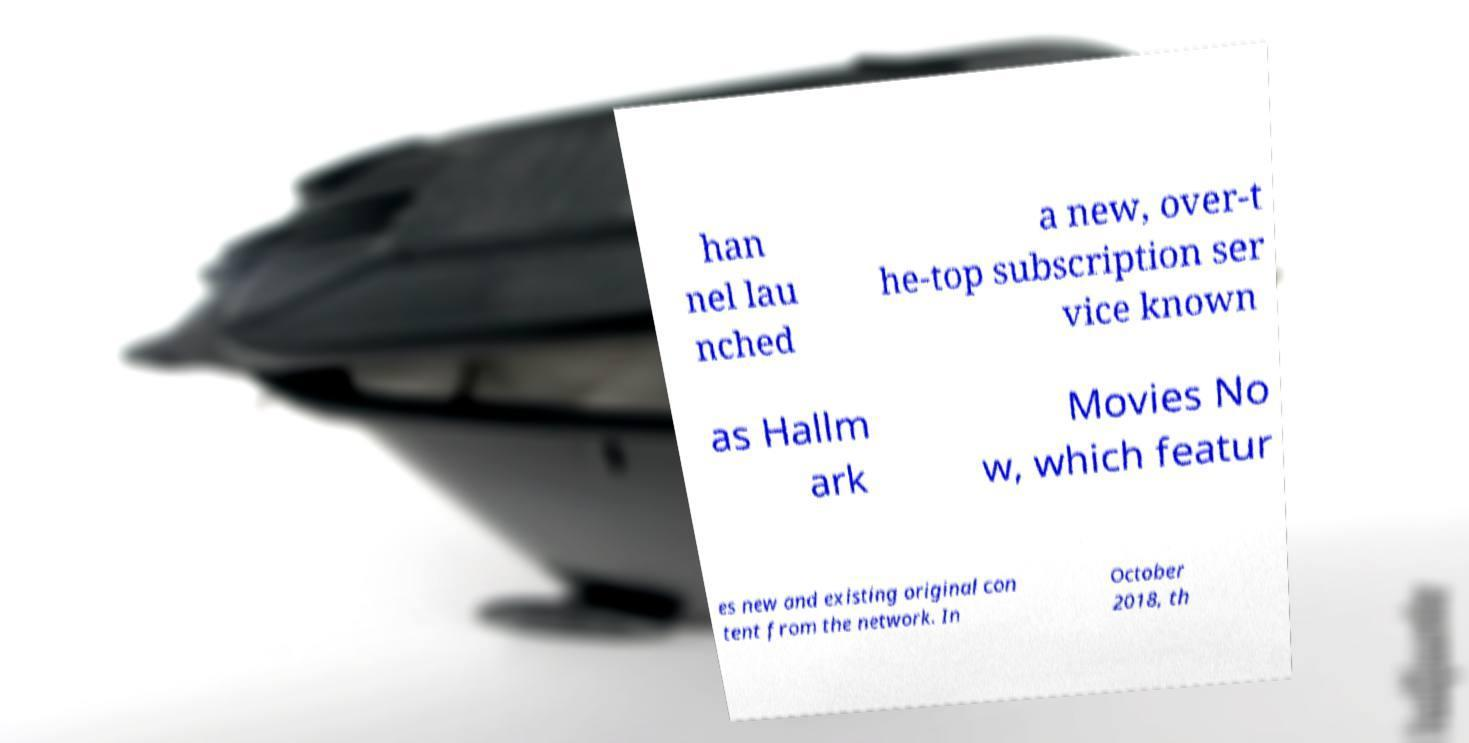Can you read and provide the text displayed in the image?This photo seems to have some interesting text. Can you extract and type it out for me? han nel lau nched a new, over-t he-top subscription ser vice known as Hallm ark Movies No w, which featur es new and existing original con tent from the network. In October 2018, th 